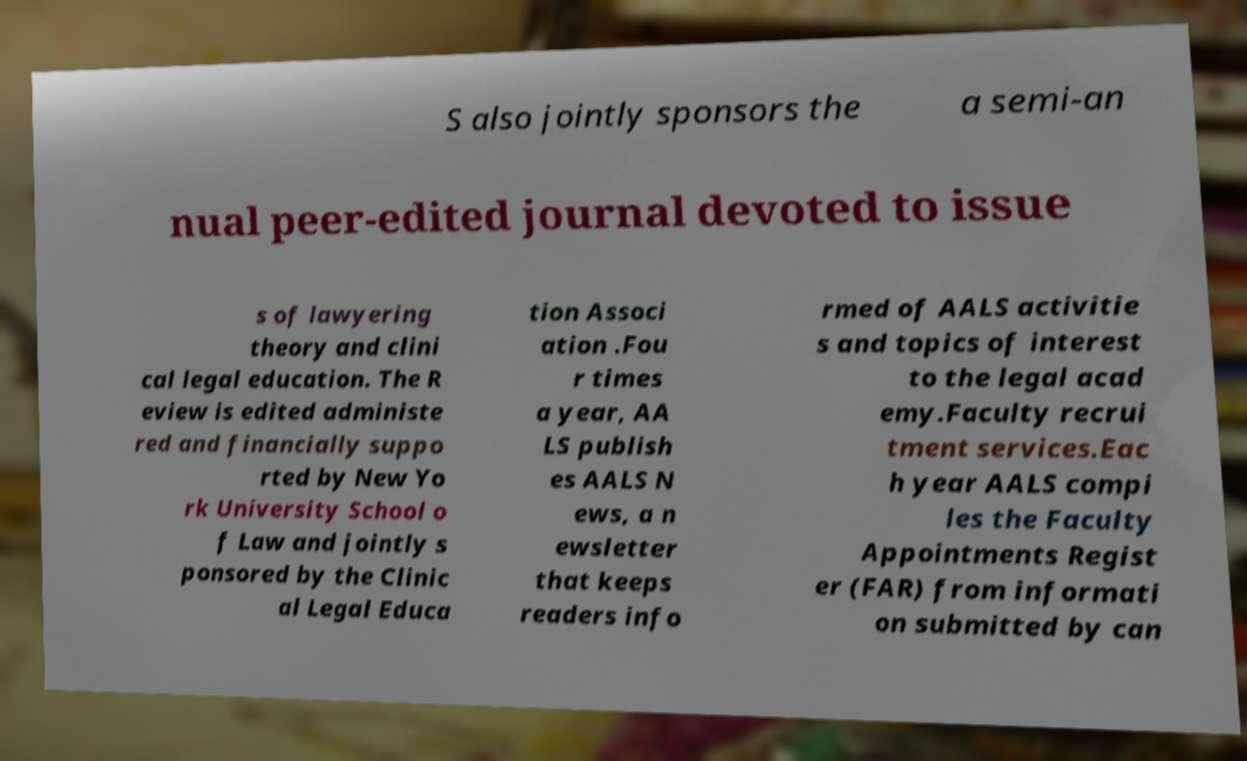Could you extract and type out the text from this image? S also jointly sponsors the a semi-an nual peer-edited journal devoted to issue s of lawyering theory and clini cal legal education. The R eview is edited administe red and financially suppo rted by New Yo rk University School o f Law and jointly s ponsored by the Clinic al Legal Educa tion Associ ation .Fou r times a year, AA LS publish es AALS N ews, a n ewsletter that keeps readers info rmed of AALS activitie s and topics of interest to the legal acad emy.Faculty recrui tment services.Eac h year AALS compi les the Faculty Appointments Regist er (FAR) from informati on submitted by can 